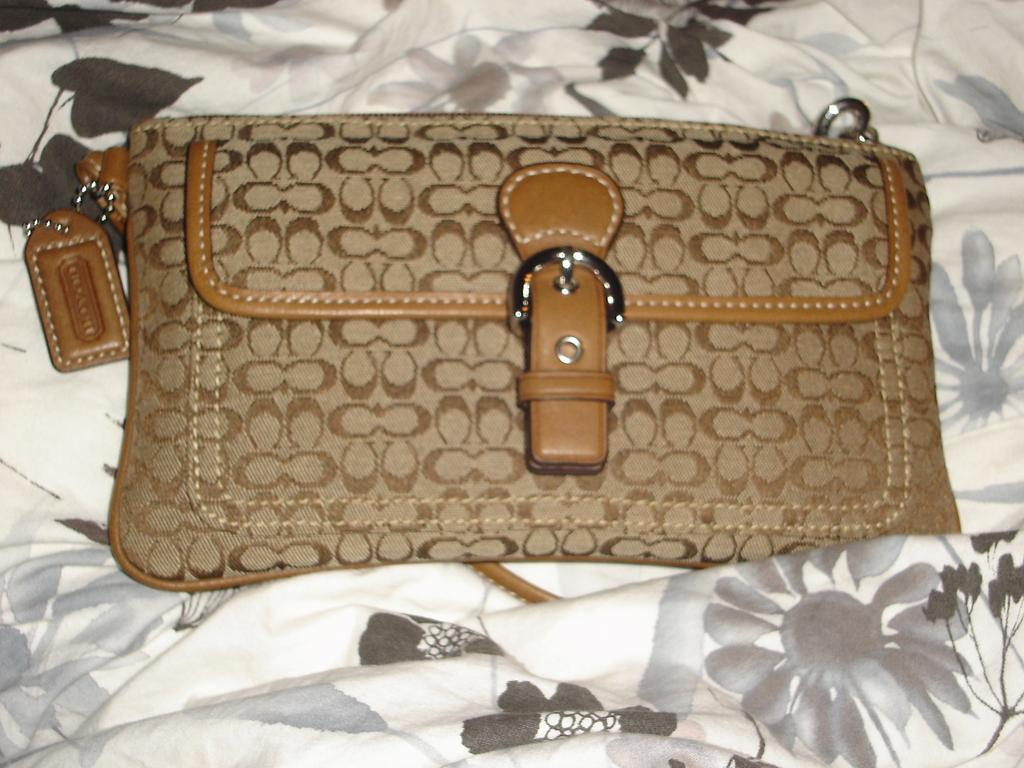What type of accessory is visible in the image? There is a handbag in the image. What type of cannon is being used to cook the meat in the image? There is no cannon or meat present in the image; it only features a handbag. 